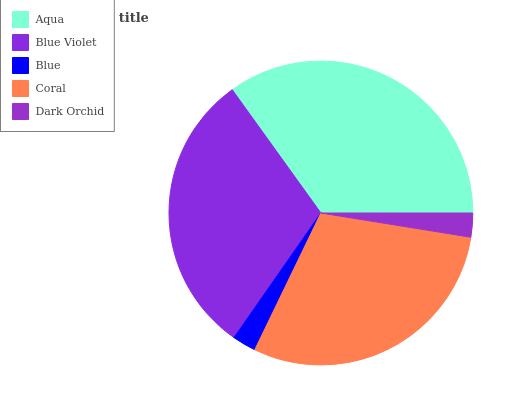Is Blue the minimum?
Answer yes or no. Yes. Is Aqua the maximum?
Answer yes or no. Yes. Is Blue Violet the minimum?
Answer yes or no. No. Is Blue Violet the maximum?
Answer yes or no. No. Is Aqua greater than Blue Violet?
Answer yes or no. Yes. Is Blue Violet less than Aqua?
Answer yes or no. Yes. Is Blue Violet greater than Aqua?
Answer yes or no. No. Is Aqua less than Blue Violet?
Answer yes or no. No. Is Coral the high median?
Answer yes or no. Yes. Is Coral the low median?
Answer yes or no. Yes. Is Blue the high median?
Answer yes or no. No. Is Dark Orchid the low median?
Answer yes or no. No. 